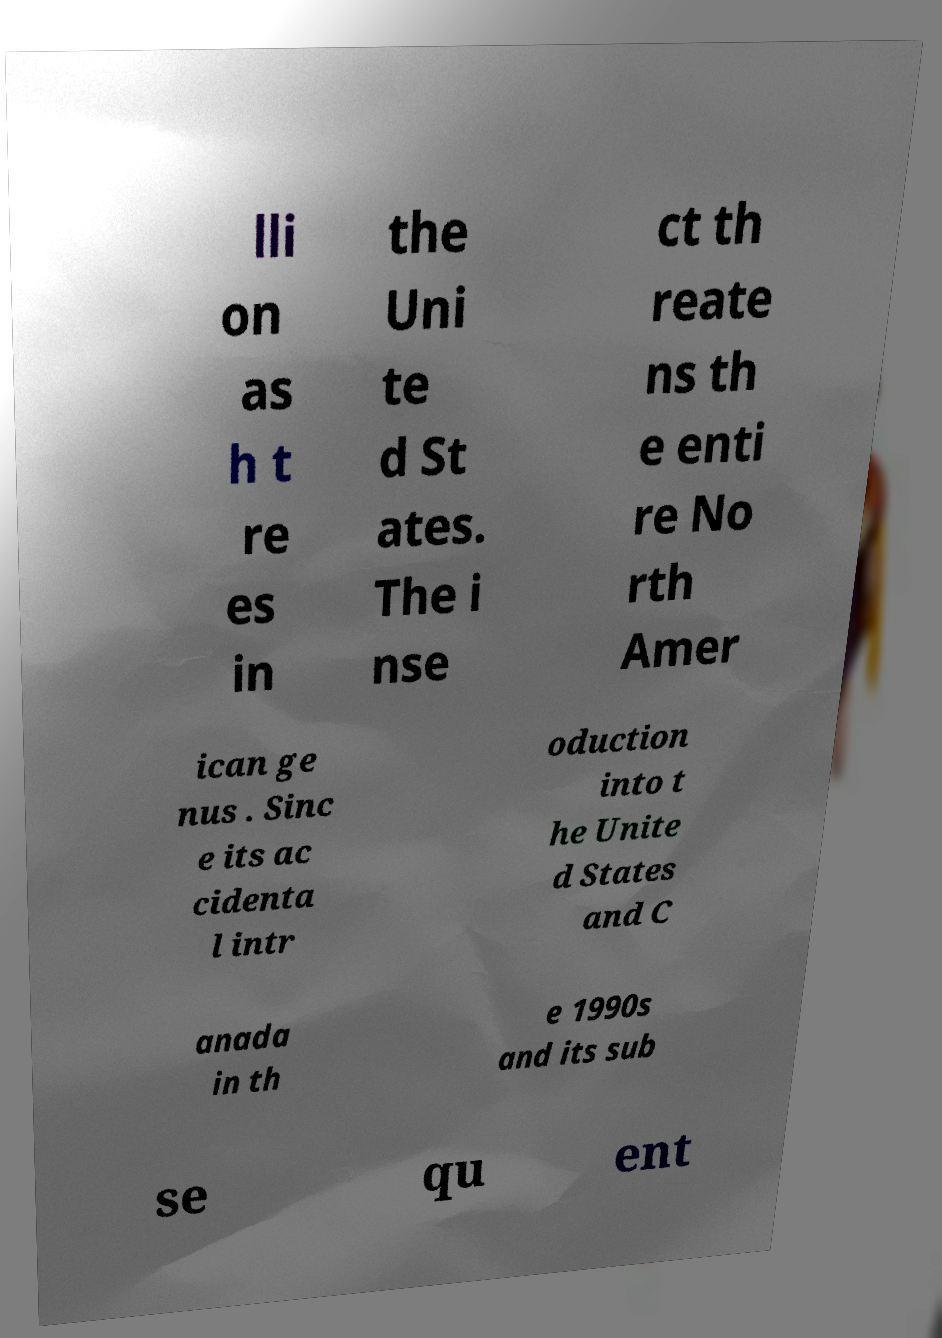Could you assist in decoding the text presented in this image and type it out clearly? lli on as h t re es in the Uni te d St ates. The i nse ct th reate ns th e enti re No rth Amer ican ge nus . Sinc e its ac cidenta l intr oduction into t he Unite d States and C anada in th e 1990s and its sub se qu ent 